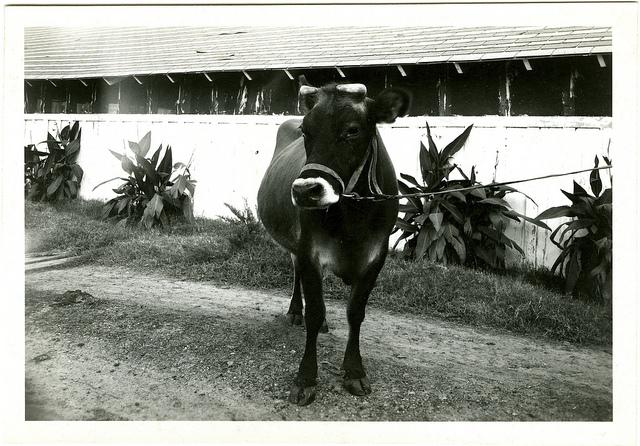Is this cow tied up?
Write a very short answer. Yes. What is the animal standing on?
Concise answer only. Dirt. What animal is this?
Write a very short answer. Cow. 